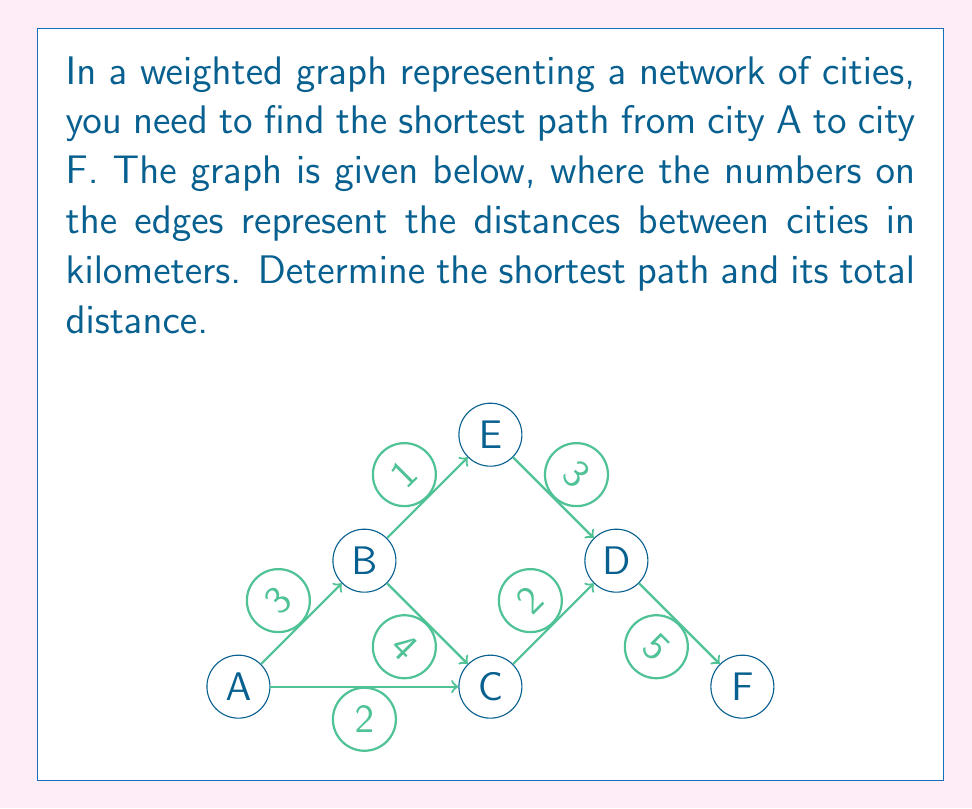Could you help me with this problem? To find the shortest path between two vertices in a weighted graph, we can use Dijkstra's algorithm. Let's apply it step by step:

1) Initialize:
   - Set distance to A as 0 and all other vertices as infinity.
   - Set A as the current vertex.

2) For the current vertex, consider all its unvisited neighbors and calculate their tentative distances.
   - From A: B(3), C(2)

3) Set A as visited. B(3) is now the vertex with the smallest tentative distance, so make it the current vertex.

4) Update distances:
   - From B: C(3+4=7 > 2, no update), E(3+1=4)

5) Set B as visited. C(2) is now the vertex with the smallest tentative distance, so make it the current vertex.

6) Update distances:
   - From C: D(2+2=4)

7) Set C as visited. D and E both have a distance of 4. Let's choose D arbitrarily.

8) Update distances:
   - From D: E(4+3=7 > 4, no update), F(4+5=9)

9) Set D as visited. E(4) is now the vertex with the smallest tentative distance.

10) Update distances:
    - From E: D(4+3=7 > 4, no update)

11) Set E as visited. F(9) is the only unvisited vertex left.

12) The algorithm terminates as we've reached F.

The shortest path is A → C → D → F with a total distance of 9 km.
Answer: The shortest path from A to F is A → C → D → F with a total distance of $9$ km. 